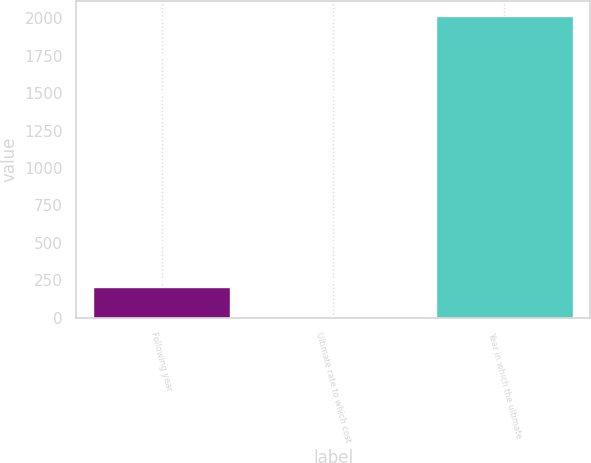<chart> <loc_0><loc_0><loc_500><loc_500><bar_chart><fcel>Following year<fcel>Ultimate rate to which cost<fcel>Year in which the ultimate<nl><fcel>205.9<fcel>5<fcel>2014<nl></chart> 